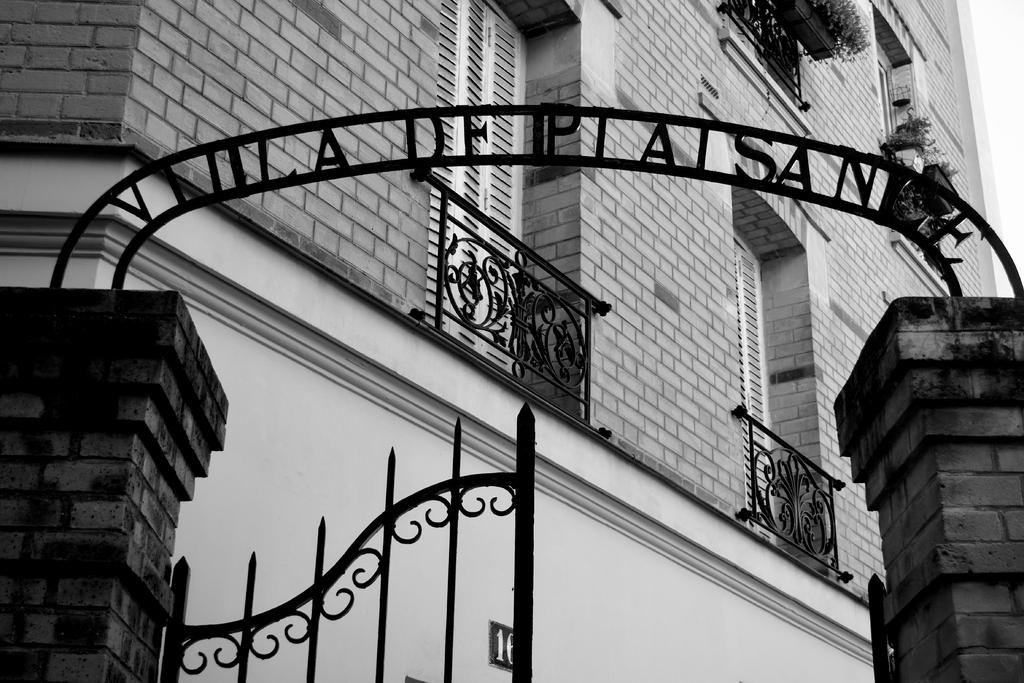What is the main structure visible in the image? There is a building in the middle of the image. What can be seen at the entrance of the building? The entrance of the building is visible in the image. What type of frame is used to hold the meal in the image? There is no meal present in the image, and therefore no frame is needed to hold it. 